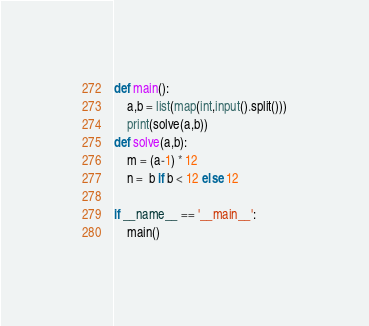<code> <loc_0><loc_0><loc_500><loc_500><_Python_>def main():
    a,b = list(map(int,input().split()))
    print(solve(a,b))
def solve(a,b):
    m = (a-1) * 12
    n =  b if b < 12 else 12

if __name__ == '__main__':
    main()
</code> 